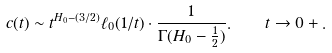<formula> <loc_0><loc_0><loc_500><loc_500>c ( t ) \sim t ^ { H _ { 0 } - ( 3 / 2 ) } \ell _ { 0 } ( 1 / t ) \cdot \frac { 1 } { \Gamma ( H _ { 0 } - \frac { 1 } { 2 } ) } . \quad t \to 0 + .</formula> 